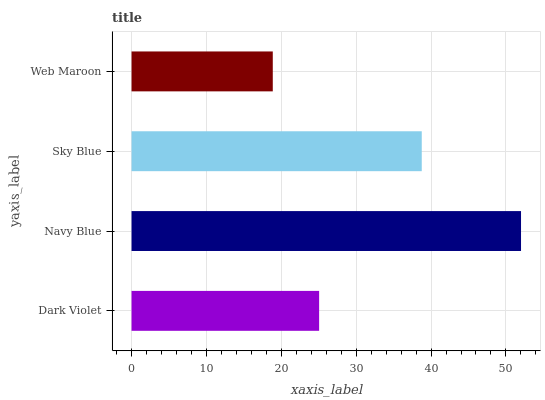Is Web Maroon the minimum?
Answer yes or no. Yes. Is Navy Blue the maximum?
Answer yes or no. Yes. Is Sky Blue the minimum?
Answer yes or no. No. Is Sky Blue the maximum?
Answer yes or no. No. Is Navy Blue greater than Sky Blue?
Answer yes or no. Yes. Is Sky Blue less than Navy Blue?
Answer yes or no. Yes. Is Sky Blue greater than Navy Blue?
Answer yes or no. No. Is Navy Blue less than Sky Blue?
Answer yes or no. No. Is Sky Blue the high median?
Answer yes or no. Yes. Is Dark Violet the low median?
Answer yes or no. Yes. Is Dark Violet the high median?
Answer yes or no. No. Is Navy Blue the low median?
Answer yes or no. No. 